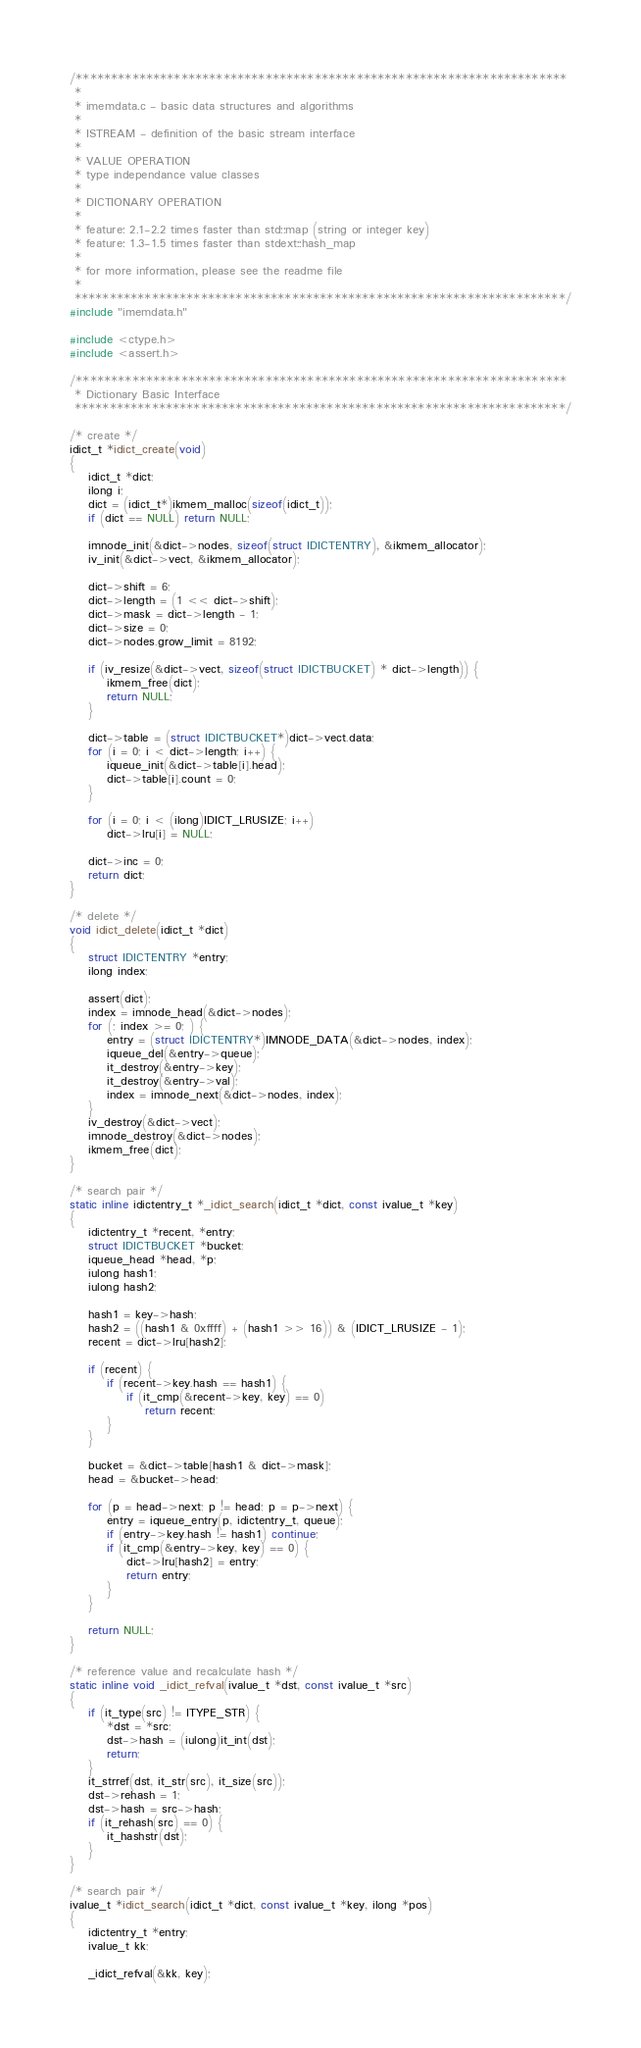<code> <loc_0><loc_0><loc_500><loc_500><_C_>/**********************************************************************
 *
 * imemdata.c - basic data structures and algorithms
 *
 * ISTREAM - definition of the basic stream interface
 *
 * VALUE OPERATION
 * type independance value classes
 *
 * DICTIONARY OPERATION
 *
 * feature: 2.1-2.2 times faster than std::map (string or integer key)
 * feature: 1.3-1.5 times faster than stdext::hash_map 
 *
 * for more information, please see the readme file
 *
 **********************************************************************/
#include "imemdata.h"

#include <ctype.h>
#include <assert.h>

/**********************************************************************
 * Dictionary Basic Interface
 **********************************************************************/

/* create */
idict_t *idict_create(void)
{
	idict_t *dict;
	ilong i;
	dict = (idict_t*)ikmem_malloc(sizeof(idict_t));
	if (dict == NULL) return NULL;

	imnode_init(&dict->nodes, sizeof(struct IDICTENTRY), &ikmem_allocator);
	iv_init(&dict->vect, &ikmem_allocator);

	dict->shift = 6;
	dict->length = (1 << dict->shift);
	dict->mask = dict->length - 1;
	dict->size = 0;
	dict->nodes.grow_limit = 8192;

	if (iv_resize(&dict->vect, sizeof(struct IDICTBUCKET) * dict->length)) {
		ikmem_free(dict);
		return NULL;
	}

	dict->table = (struct IDICTBUCKET*)dict->vect.data;
	for (i = 0; i < dict->length; i++) {
		iqueue_init(&dict->table[i].head);
		dict->table[i].count = 0;
	}

	for (i = 0; i < (ilong)IDICT_LRUSIZE; i++) 
		dict->lru[i] = NULL;

	dict->inc = 0;
	return dict;
}

/* delete */
void idict_delete(idict_t *dict)
{
	struct IDICTENTRY *entry;
	ilong index;

	assert(dict);
	index = imnode_head(&dict->nodes);
	for (; index >= 0; ) {
		entry = (struct IDICTENTRY*)IMNODE_DATA(&dict->nodes, index);
		iqueue_del(&entry->queue);
		it_destroy(&entry->key);
		it_destroy(&entry->val);
		index = imnode_next(&dict->nodes, index);
	}
	iv_destroy(&dict->vect);
	imnode_destroy(&dict->nodes);
	ikmem_free(dict);
}

/* search pair */
static inline idictentry_t *_idict_search(idict_t *dict, const ivalue_t *key)
{
	idictentry_t *recent, *entry;
	struct IDICTBUCKET *bucket;
	iqueue_head *head, *p;
	iulong hash1;
	iulong hash2;

	hash1 = key->hash;
	hash2 = ((hash1 & 0xffff) + (hash1 >> 16)) & (IDICT_LRUSIZE - 1);
	recent = dict->lru[hash2];

	if (recent) {
		if (recent->key.hash == hash1) {
			if (it_cmp(&recent->key, key) == 0) 
				return recent;
		}
	}

	bucket = &dict->table[hash1 & dict->mask];
	head = &bucket->head;

	for (p = head->next; p != head; p = p->next) {
		entry = iqueue_entry(p, idictentry_t, queue);
		if (entry->key.hash != hash1) continue;
		if (it_cmp(&entry->key, key) == 0) {
			dict->lru[hash2] = entry;
			return entry;
		}
	}

	return NULL;
}

/* reference value and recalculate hash */
static inline void _idict_refval(ivalue_t *dst, const ivalue_t *src)
{
	if (it_type(src) != ITYPE_STR) {
		*dst = *src;
		dst->hash = (iulong)it_int(dst);
		return;
	}
	it_strref(dst, it_str(src), it_size(src));
	dst->rehash = 1;
	dst->hash = src->hash;
	if (it_rehash(src) == 0) {
		it_hashstr(dst);
	}
}

/* search pair */
ivalue_t *idict_search(idict_t *dict, const ivalue_t *key, ilong *pos)
{
	idictentry_t *entry;
	ivalue_t kk;

	_idict_refval(&kk, key);</code> 